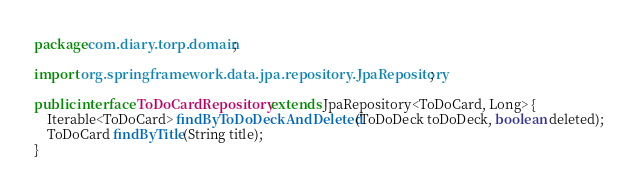<code> <loc_0><loc_0><loc_500><loc_500><_Java_>package com.diary.torp.domain;

import org.springframework.data.jpa.repository.JpaRepository;

public interface ToDoCardRepository extends JpaRepository<ToDoCard, Long> {
    Iterable<ToDoCard> findByToDoDeckAndDeleted(ToDoDeck toDoDeck, boolean deleted);
    ToDoCard findByTitle(String title);
}</code> 